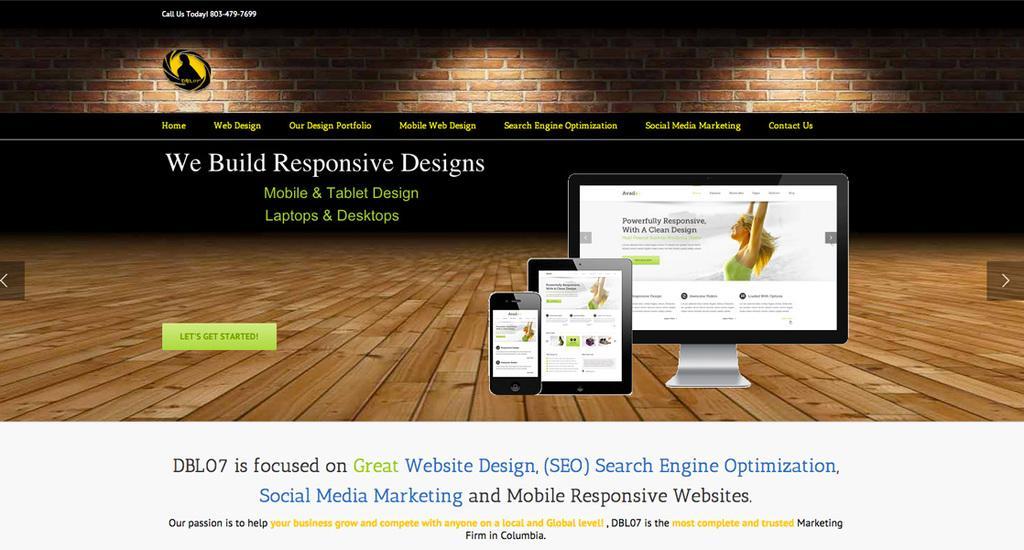Describe this image in one or two sentences. In this image we can see there is some text and there is a monitor, tab, mobile, wooden floor, wall with red bricks. At the bottom of the image there is some text. 